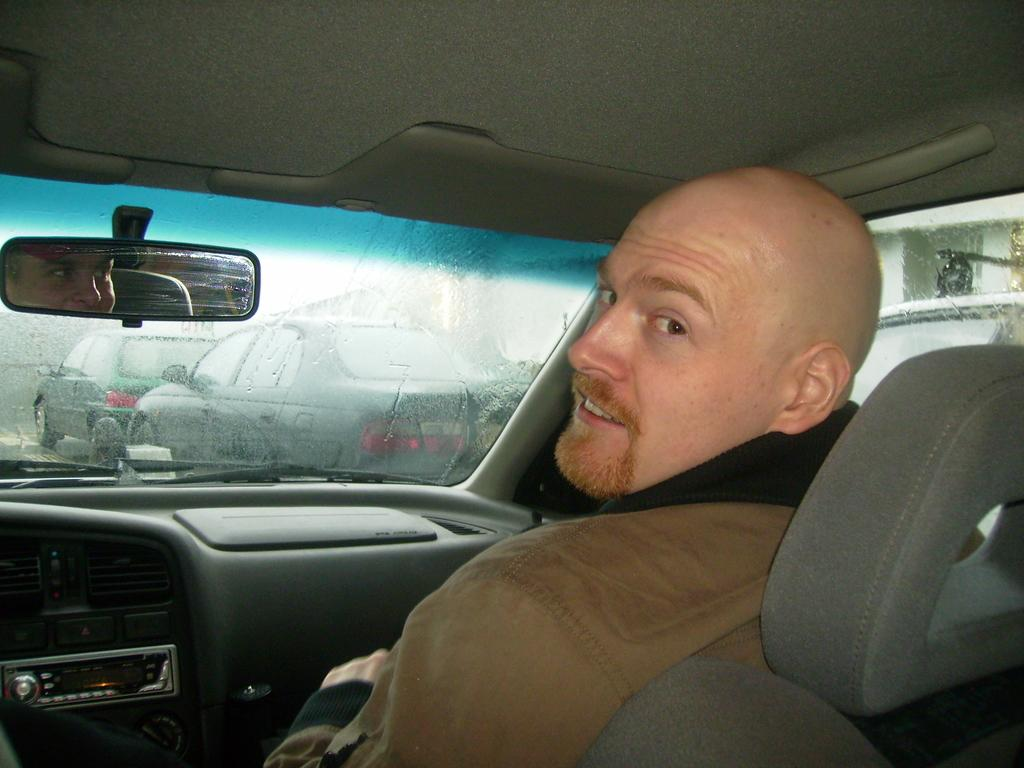What is inside the car in the image? There is a person in the car. What type of window is present on the car? The car has a glass window. What can be seen through the car's window? Other vehicles are visible on the road through the car's window. What type of drain is visible in the image? There is no drain present in the image; it features a person in a car with a glass window and other vehicles visible on the road. 